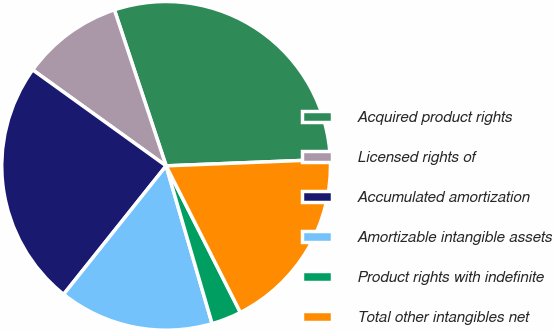<chart> <loc_0><loc_0><loc_500><loc_500><pie_chart><fcel>Acquired product rights<fcel>Licensed rights of<fcel>Accumulated amortization<fcel>Amortizable intangible assets<fcel>Product rights with indefinite<fcel>Total other intangibles net<nl><fcel>29.46%<fcel>9.98%<fcel>24.21%<fcel>15.23%<fcel>2.95%<fcel>18.17%<nl></chart> 